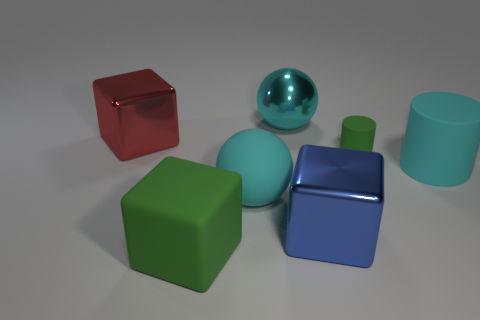Are there any other things that have the same size as the green cylinder?
Offer a very short reply. No. There is a large metal object that is to the left of the large metal ball; is it the same shape as the matte thing in front of the large cyan rubber ball?
Your response must be concise. Yes. Is there any other thing that has the same color as the rubber block?
Keep it short and to the point. Yes. What is the shape of the small green thing that is made of the same material as the green block?
Provide a succinct answer. Cylinder. What is the big thing that is in front of the large rubber cylinder and behind the blue shiny block made of?
Make the answer very short. Rubber. Is the small thing the same color as the big rubber cylinder?
Offer a very short reply. No. The small object that is the same color as the rubber cube is what shape?
Your answer should be very brief. Cylinder. How many green things have the same shape as the big blue thing?
Provide a succinct answer. 1. What size is the block that is the same material as the tiny object?
Your answer should be very brief. Large. Is the size of the blue thing the same as the red metal object?
Make the answer very short. Yes. 